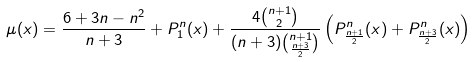<formula> <loc_0><loc_0><loc_500><loc_500>\mu ( x ) = \frac { 6 + 3 n - n ^ { 2 } } { n + 3 } + P _ { 1 } ^ { n } ( x ) + \frac { 4 \binom { n + 1 } { 2 } } { ( n + 3 ) \binom { n + 1 } { \frac { n + 3 } { 2 } } } \left ( P _ { \frac { n + 1 } { 2 } } ^ { n } ( x ) + P _ { \frac { n + 3 } { 2 } } ^ { n } ( x ) \right )</formula> 